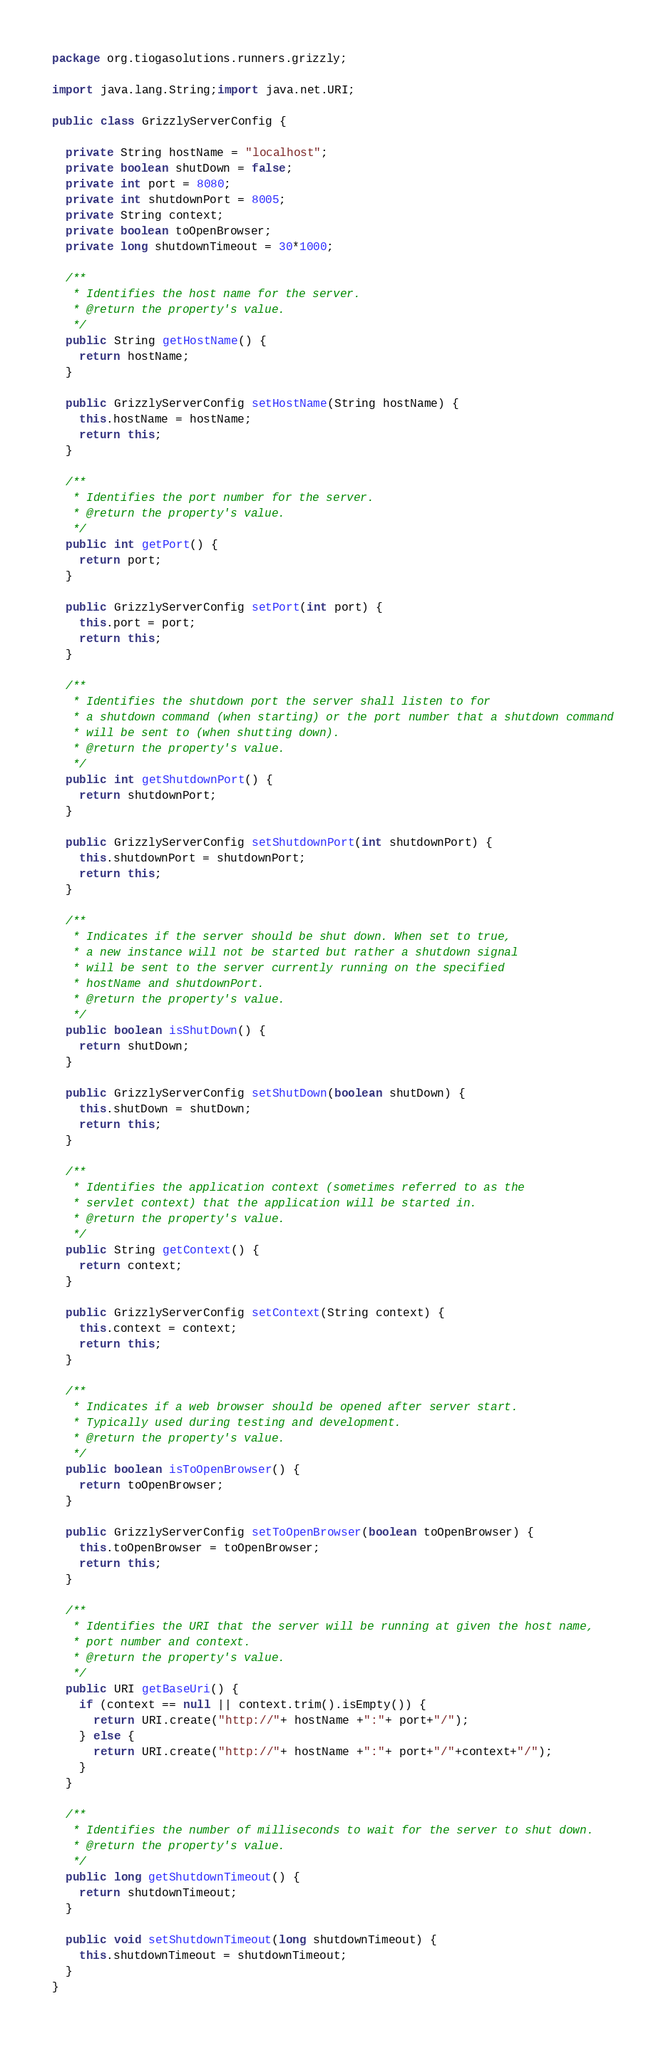Convert code to text. <code><loc_0><loc_0><loc_500><loc_500><_Java_>package org.tiogasolutions.runners.grizzly;

import java.lang.String;import java.net.URI;

public class GrizzlyServerConfig {

  private String hostName = "localhost";
  private boolean shutDown = false;
  private int port = 8080;
  private int shutdownPort = 8005;
  private String context;
  private boolean toOpenBrowser;
  private long shutdownTimeout = 30*1000;

  /**
   * Identifies the host name for the server.
   * @return the property's value.
   */
  public String getHostName() {
    return hostName;
  }

  public GrizzlyServerConfig setHostName(String hostName) {
    this.hostName = hostName;
    return this;
  }

  /**
   * Identifies the port number for the server.
   * @return the property's value.
   */
  public int getPort() {
    return port;
  }

  public GrizzlyServerConfig setPort(int port) {
    this.port = port;
    return this;
  }

  /**
   * Identifies the shutdown port the server shall listen to for
   * a shutdown command (when starting) or the port number that a shutdown command
   * will be sent to (when shutting down).
   * @return the property's value.
   */
  public int getShutdownPort() {
    return shutdownPort;
  }

  public GrizzlyServerConfig setShutdownPort(int shutdownPort) {
    this.shutdownPort = shutdownPort;
    return this;
  }

  /**
   * Indicates if the server should be shut down. When set to true,
   * a new instance will not be started but rather a shutdown signal
   * will be sent to the server currently running on the specified
   * hostName and shutdownPort.
   * @return the property's value.
   */
  public boolean isShutDown() {
    return shutDown;
  }

  public GrizzlyServerConfig setShutDown(boolean shutDown) {
    this.shutDown = shutDown;
    return this;
  }

  /**
   * Identifies the application context (sometimes referred to as the
   * servlet context) that the application will be started in.
   * @return the property's value.
   */
  public String getContext() {
    return context;
  }

  public GrizzlyServerConfig setContext(String context) {
    this.context = context;
    return this;
  }

  /**
   * Indicates if a web browser should be opened after server start.
   * Typically used during testing and development.
   * @return the property's value.
   */
  public boolean isToOpenBrowser() {
    return toOpenBrowser;
  }

  public GrizzlyServerConfig setToOpenBrowser(boolean toOpenBrowser) {
    this.toOpenBrowser = toOpenBrowser;
    return this;
  }

  /**
   * Identifies the URI that the server will be running at given the host name,
   * port number and context.
   * @return the property's value.
   */
  public URI getBaseUri() {
    if (context == null || context.trim().isEmpty()) {
      return URI.create("http://"+ hostName +":"+ port+"/");
    } else {
      return URI.create("http://"+ hostName +":"+ port+"/"+context+"/");
    }
  }

  /**
   * Identifies the number of milliseconds to wait for the server to shut down.
   * @return the property's value.
   */
  public long getShutdownTimeout() {
    return shutdownTimeout;
  }

  public void setShutdownTimeout(long shutdownTimeout) {
    this.shutdownTimeout = shutdownTimeout;
  }
}
</code> 